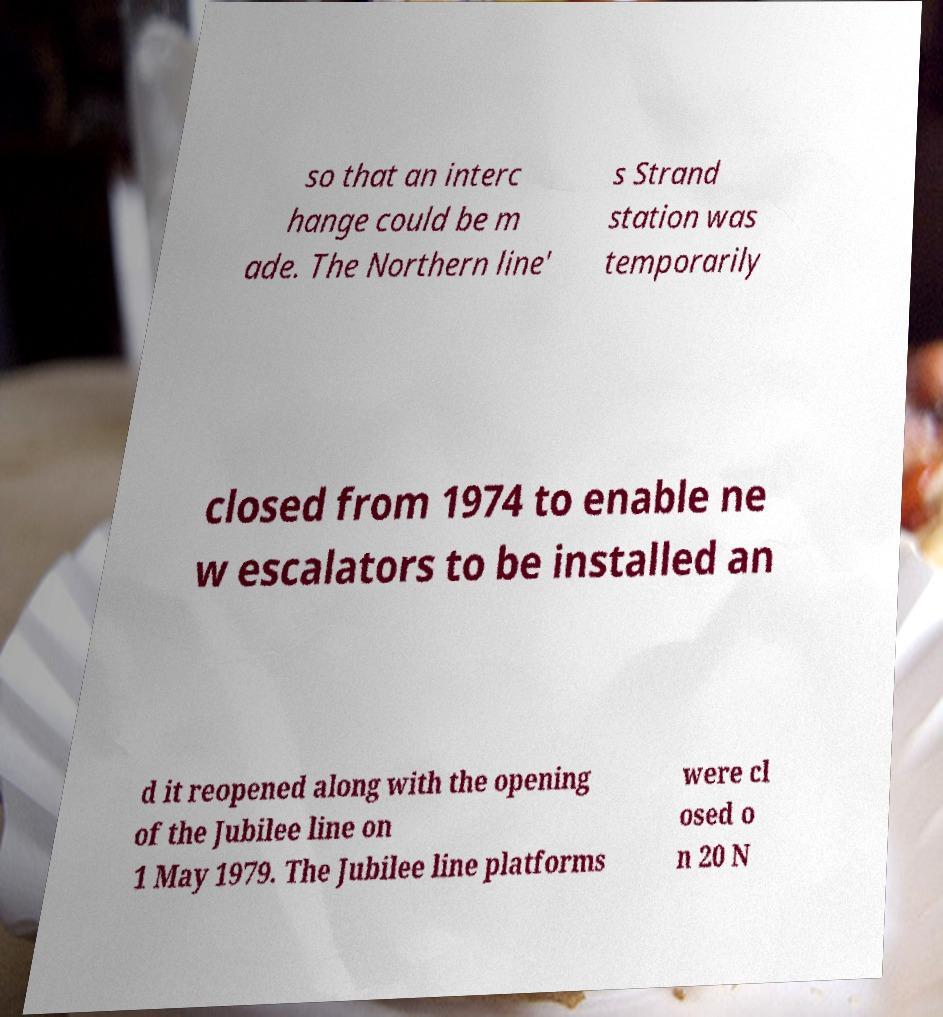Please identify and transcribe the text found in this image. so that an interc hange could be m ade. The Northern line' s Strand station was temporarily closed from 1974 to enable ne w escalators to be installed an d it reopened along with the opening of the Jubilee line on 1 May 1979. The Jubilee line platforms were cl osed o n 20 N 